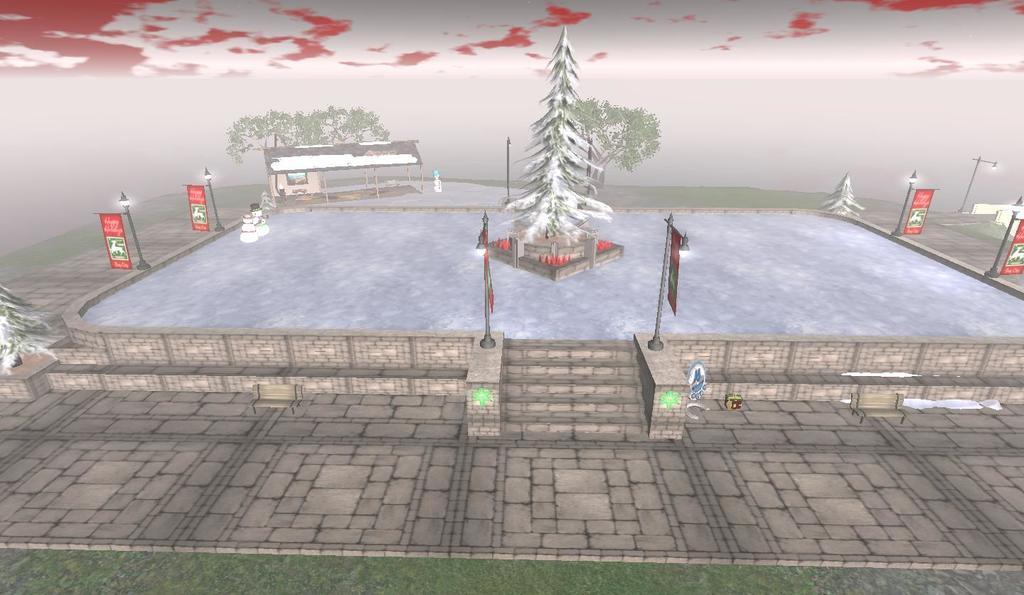In one or two sentences, can you explain what this image depicts? This is a graphical picture and in this picture we can see the ground, grass, trees, poles, posters, snowmen, shelter, some objects and in the background we can see the sky. 